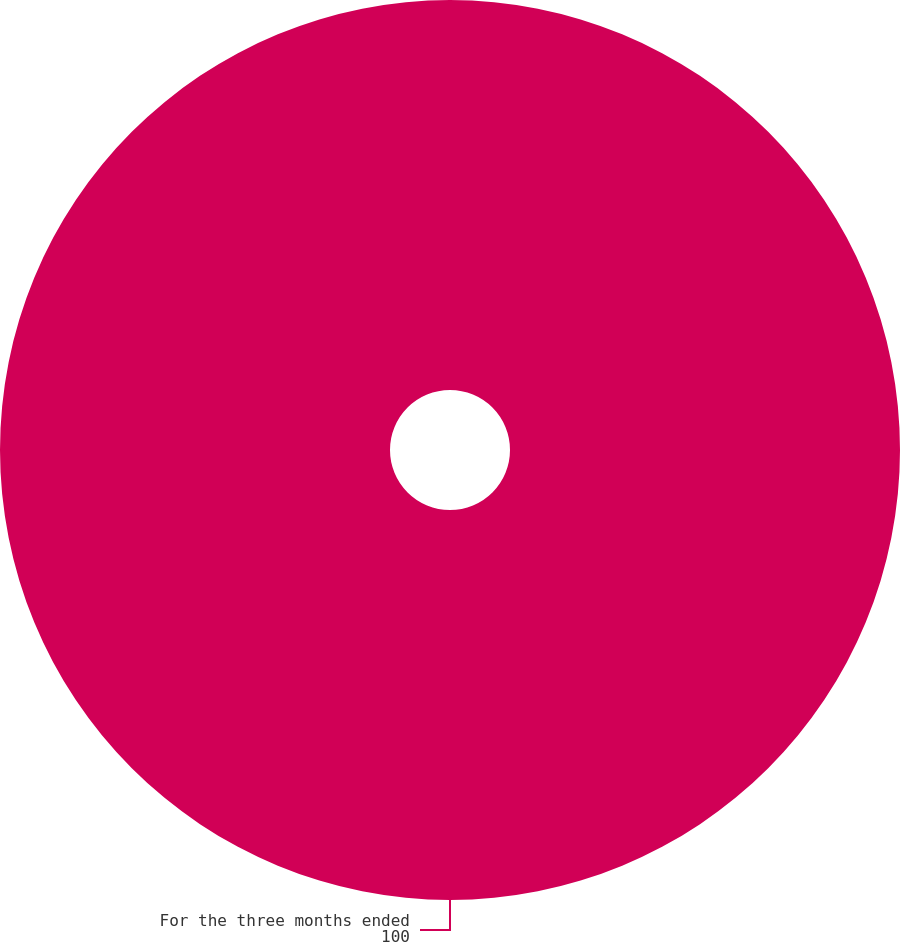<chart> <loc_0><loc_0><loc_500><loc_500><pie_chart><fcel>For the three months ended<nl><fcel>100.0%<nl></chart> 